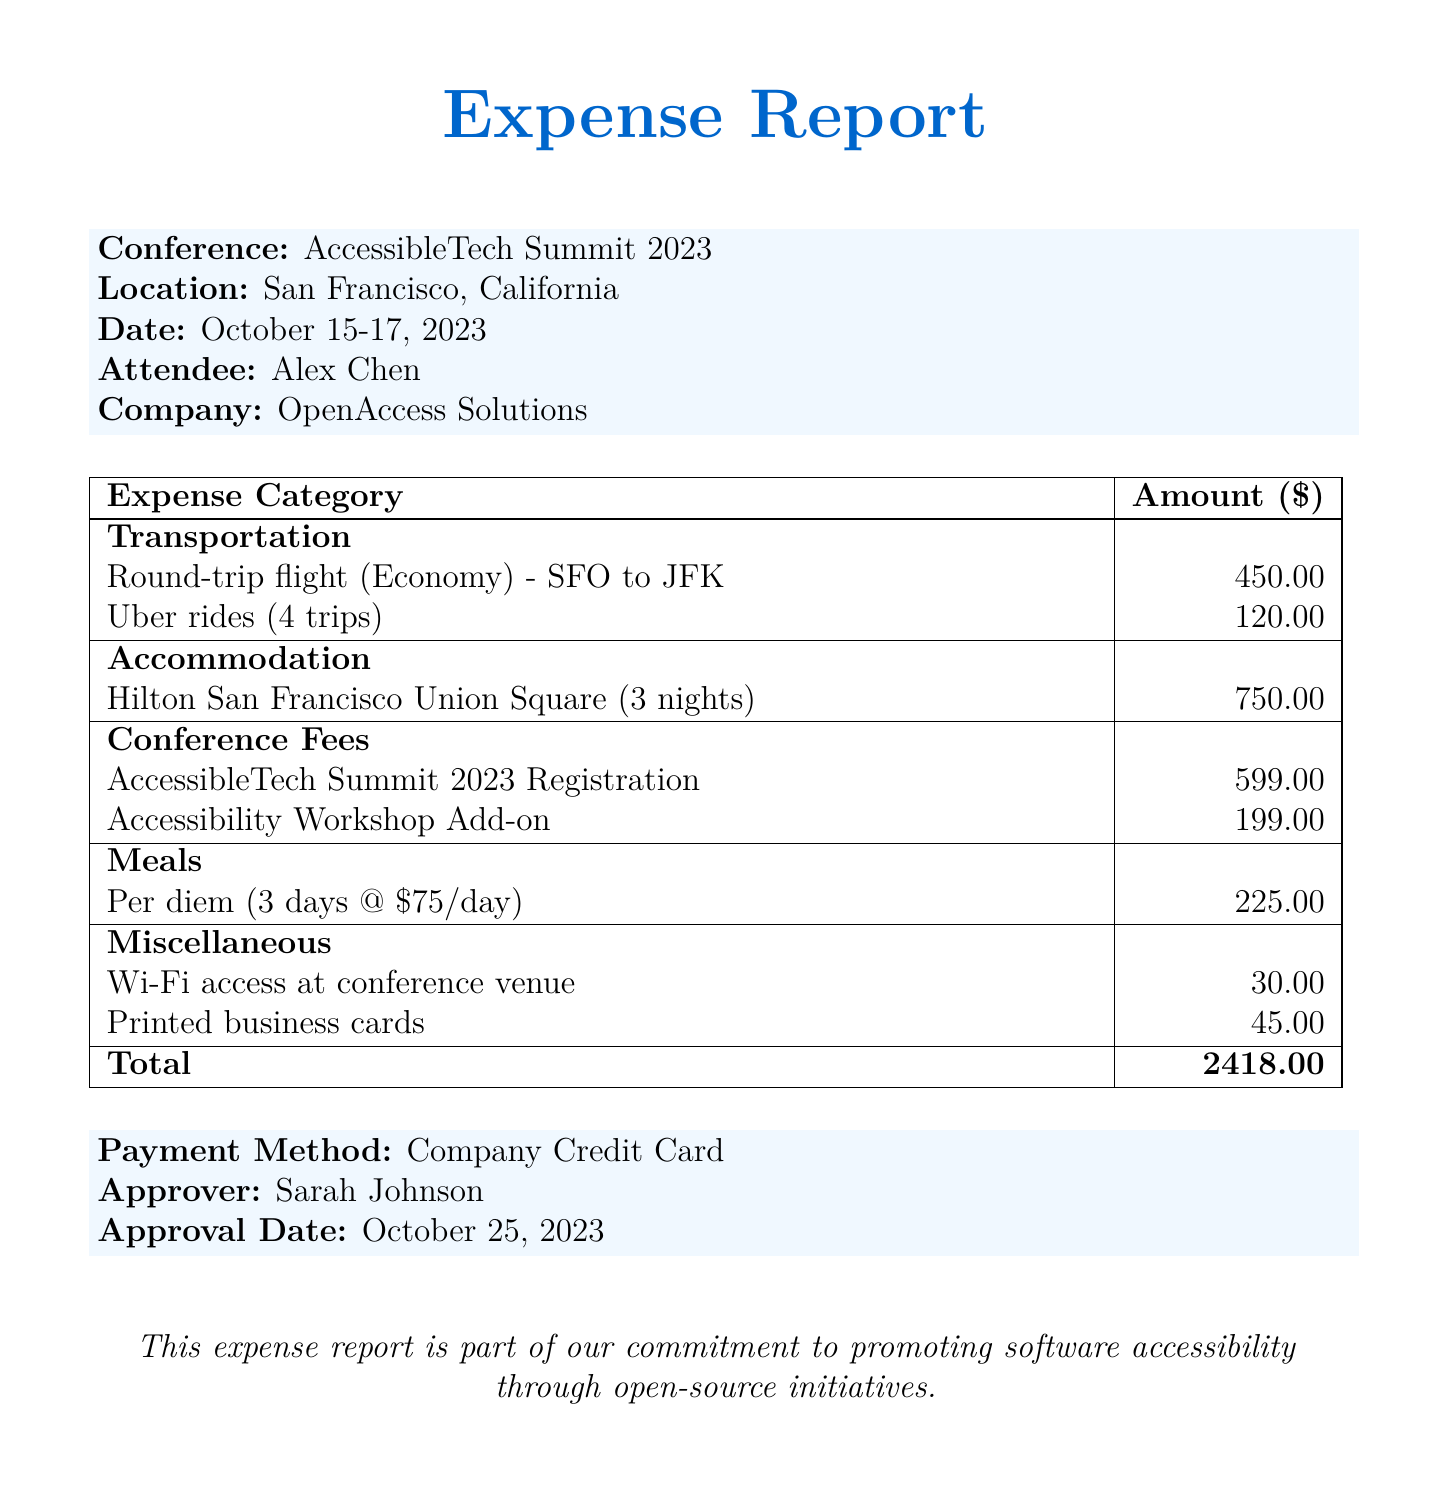What was the date of the AccessibleTech Summit 2023? The date of the conference is mentioned as October 15-17, 2023.
Answer: October 15-17, 2023 Who approved the expense report? The approver's name is listed prominently in the document as Sarah Johnson.
Answer: Sarah Johnson What is the total expense amount? The total sum of all listed expenses in the report is $2418.00.
Answer: 2418.00 How many nights was the accommodation booked for? The accommodation details state that it was for 3 nights.
Answer: 3 nights What was the cost of the round-trip flight? The document specifies the round-trip flight cost as $450.00.
Answer: 450.00 What was the per diem amount for meals? The per diem for meals is shown as $75/day for 3 days, totaling $225.00.
Answer: $225.00 What type of credit card was used for the payment? The payment method stated in the document is "Company Credit Card."
Answer: Company Credit Card How many Uber rides were taken during the trip? The report mentions a total of 4 Uber rides.
Answer: 4 trips What additional feature was included in the conference registration? The document mentions an "Accessibility Workshop Add-on" as an additional feature.
Answer: Accessibility Workshop Add-on 